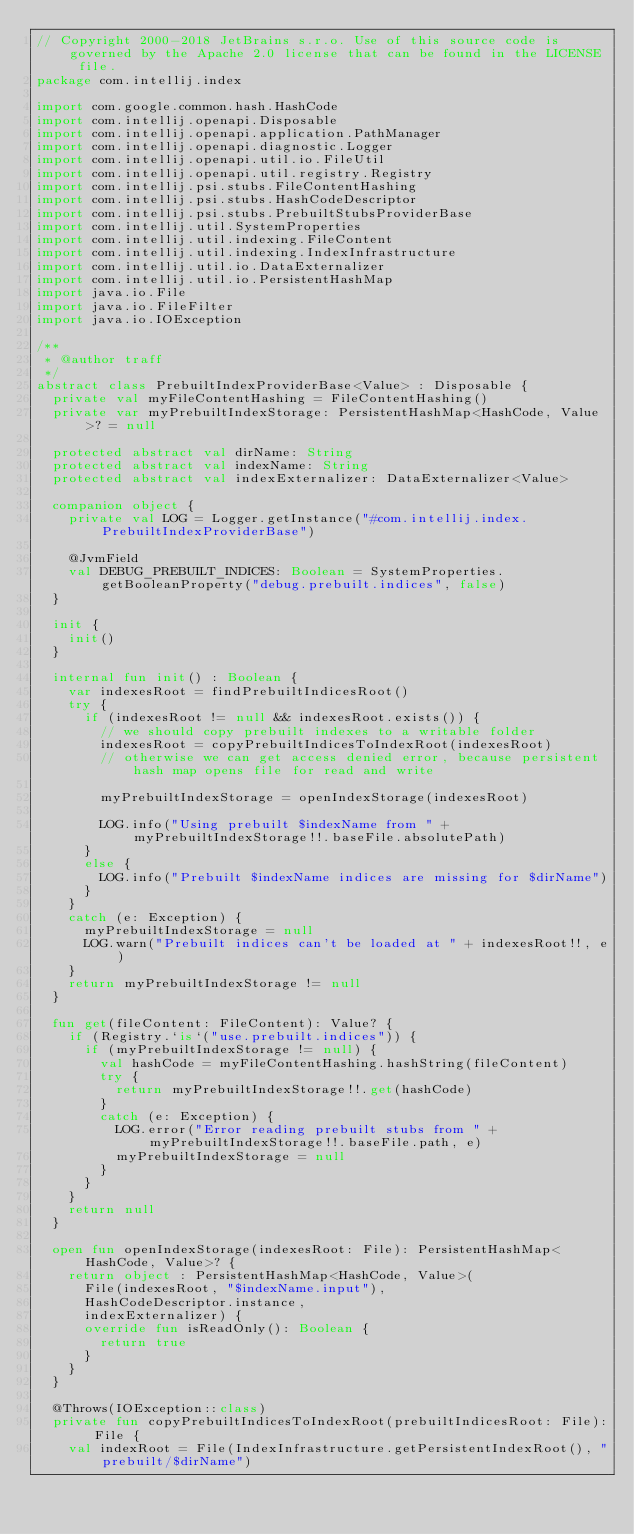Convert code to text. <code><loc_0><loc_0><loc_500><loc_500><_Kotlin_>// Copyright 2000-2018 JetBrains s.r.o. Use of this source code is governed by the Apache 2.0 license that can be found in the LICENSE file.
package com.intellij.index

import com.google.common.hash.HashCode
import com.intellij.openapi.Disposable
import com.intellij.openapi.application.PathManager
import com.intellij.openapi.diagnostic.Logger
import com.intellij.openapi.util.io.FileUtil
import com.intellij.openapi.util.registry.Registry
import com.intellij.psi.stubs.FileContentHashing
import com.intellij.psi.stubs.HashCodeDescriptor
import com.intellij.psi.stubs.PrebuiltStubsProviderBase
import com.intellij.util.SystemProperties
import com.intellij.util.indexing.FileContent
import com.intellij.util.indexing.IndexInfrastructure
import com.intellij.util.io.DataExternalizer
import com.intellij.util.io.PersistentHashMap
import java.io.File
import java.io.FileFilter
import java.io.IOException

/**
 * @author traff
 */
abstract class PrebuiltIndexProviderBase<Value> : Disposable {
  private val myFileContentHashing = FileContentHashing()
  private var myPrebuiltIndexStorage: PersistentHashMap<HashCode, Value>? = null

  protected abstract val dirName: String
  protected abstract val indexName: String
  protected abstract val indexExternalizer: DataExternalizer<Value>

  companion object {
    private val LOG = Logger.getInstance("#com.intellij.index.PrebuiltIndexProviderBase")

    @JvmField
    val DEBUG_PREBUILT_INDICES: Boolean = SystemProperties.getBooleanProperty("debug.prebuilt.indices", false)
  }

  init {
    init()
  }

  internal fun init() : Boolean {
    var indexesRoot = findPrebuiltIndicesRoot()
    try {
      if (indexesRoot != null && indexesRoot.exists()) {
        // we should copy prebuilt indexes to a writable folder
        indexesRoot = copyPrebuiltIndicesToIndexRoot(indexesRoot)
        // otherwise we can get access denied error, because persistent hash map opens file for read and write

        myPrebuiltIndexStorage = openIndexStorage(indexesRoot)

        LOG.info("Using prebuilt $indexName from " + myPrebuiltIndexStorage!!.baseFile.absolutePath)
      }
      else {
        LOG.info("Prebuilt $indexName indices are missing for $dirName")
      }
    }
    catch (e: Exception) {
      myPrebuiltIndexStorage = null
      LOG.warn("Prebuilt indices can't be loaded at " + indexesRoot!!, e)
    }
    return myPrebuiltIndexStorage != null
  }

  fun get(fileContent: FileContent): Value? {
    if (Registry.`is`("use.prebuilt.indices")) {
      if (myPrebuiltIndexStorage != null) {
        val hashCode = myFileContentHashing.hashString(fileContent)
        try {
          return myPrebuiltIndexStorage!!.get(hashCode)
        }
        catch (e: Exception) {
          LOG.error("Error reading prebuilt stubs from " + myPrebuiltIndexStorage!!.baseFile.path, e)
          myPrebuiltIndexStorage = null
        }
      }
    }
    return null
  }

  open fun openIndexStorage(indexesRoot: File): PersistentHashMap<HashCode, Value>? {
    return object : PersistentHashMap<HashCode, Value>(
      File(indexesRoot, "$indexName.input"),
      HashCodeDescriptor.instance,
      indexExternalizer) {
      override fun isReadOnly(): Boolean {
        return true
      }
    }
  }

  @Throws(IOException::class)
  private fun copyPrebuiltIndicesToIndexRoot(prebuiltIndicesRoot: File): File {
    val indexRoot = File(IndexInfrastructure.getPersistentIndexRoot(), "prebuilt/$dirName")
</code> 